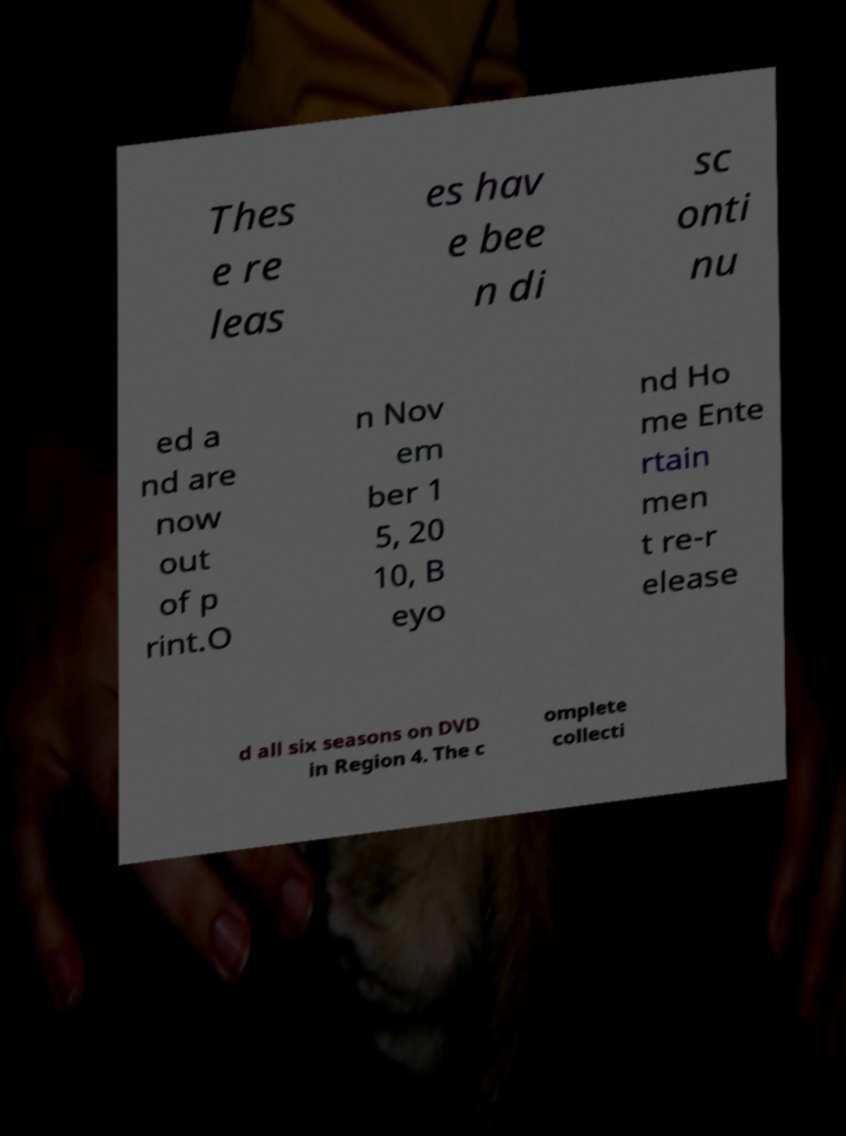Can you accurately transcribe the text from the provided image for me? Thes e re leas es hav e bee n di sc onti nu ed a nd are now out of p rint.O n Nov em ber 1 5, 20 10, B eyo nd Ho me Ente rtain men t re-r elease d all six seasons on DVD in Region 4. The c omplete collecti 